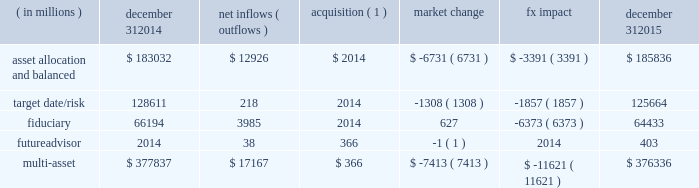Long-term product offerings include active and index strategies .
Our active strategies seek to earn attractive returns in excess of a market benchmark or performance hurdle while maintaining an appropriate risk profile .
We offer two types of active strategies : those that rely primarily on fundamental research and those that utilize primarily quantitative models to drive portfolio construction .
In contrast , index strategies seek to closely track the returns of a corresponding index , generally by investing in substantially the same underlying securities within the index or in a subset of those securities selected to approximate a similar risk and return profile of the index .
Index strategies include both our non-etf index products and ishares etfs .
Althoughmany clients use both active and index strategies , the application of these strategies may differ .
For example , clients may use index products to gain exposure to a market or asset class .
In addition , institutional non-etf index assignments tend to be very large ( multi-billion dollars ) and typically reflect low fee rates .
This has the potential to exaggerate the significance of net flows in institutional index products on blackrock 2019s revenues and earnings .
Equity year-end 2015 equity aum totaled $ 2.424 trillion , reflecting net inflows of $ 52.8 billion .
Net inflows included $ 78.4 billion and $ 4.2 billion into ishares and active products , respectively .
Ishares net inflows were driven by the core series and flows into broad developed market equity exposures , and active net inflows reflected demand for international equities .
Ishares and active net inflows were partially offset by non-etf index net outflows of $ 29.8 billion .
Blackrock 2019s effective fee rates fluctuate due to changes in aummix .
Approximately half of blackrock 2019s equity aum is tied to international markets , including emerging markets , which tend to have higher fee rates than u.s .
Equity strategies .
Accordingly , fluctuations in international equity markets , which do not consistently move in tandemwith u.s .
Markets , may have a greater impact on blackrock 2019s effective equity fee rates and revenues .
Fixed income fixed income aum ended 2015 at $ 1.422 trillion , increasing $ 28.7 billion , or 2% ( 2 % ) , from december 31 , 2014 .
The increase in aum reflected $ 76.9 billion in net inflows , partially offset by $ 48.2 billion in net market depreciation and foreign exchange movements .
In 2015 , active net inflows of $ 35.9 billion were diversified across fixed income offerings , with strong flows into our unconstrained , total return and high yield strategies .
Flagship funds in these product areas include our unconstrained strategic income opportunities and fixed income strategies funds , with net inflows of $ 7.0 billion and $ 3.7 billion , respectively ; our total return fund with net inflows of $ 2.7 billion ; and our high yield bond fund with net inflows of $ 3.5 billion .
Fixed income ishares net inflows of $ 50.3 billion were led by flows into core , corporate and high yield bond funds .
Active and ishares net inflows were partially offset by non-etf index net outflows of $ 9.3 billion .
Multi-asset class blackrock 2019s multi-asset class teammanages a variety of balanced funds and bespoke mandates for a diversified client base that leverages our broad investment expertise in global equities , bonds , currencies and commodities , and our extensive risk management capabilities .
Investment solutions might include a combination of long-only portfolios and alternative investments as well as tactical asset allocation overlays .
Component changes in multi-asset class aum for 2015 are presented below .
( in millions ) december 31 , 2014 net inflows ( outflows ) acquisition ( 1 ) market change fx impact december 31 , 2015 asset allocation and balanced $ 183032 $ 12926 $ 2014 $ ( 6731 ) $ ( 3391 ) $ 185836 .
( 1 ) amounts represent $ 366 million of aum acquired in the futureadvisor acquisition in october 2015 .
The futureadvisor acquisition amount does not include aum that was held in ishares holdings .
Multi-asset class net inflows reflected ongoing institutional demand for our solutions-based advice with $ 17.4 billion of net inflows coming from institutional clients .
Defined contribution plans of institutional clients remained a significant driver of flows , and contributed $ 7.3 billion to institutional multi-asset class net new business in 2015 , primarily into target date and target risk product offerings .
Retail net outflows of $ 1.3 billion were primarily due to a large single-client transition out of mutual funds into a series of ishares across asset classes .
Notwithstanding this transition , retail flows reflected demand for our multi-asset income fund family , which raised $ 4.6 billion in 2015 .
The company 2019s multi-asset class strategies include the following : 2022 asset allocation and balanced products represented 49% ( 49 % ) of multi-asset class aum at year-end , with growth in aum driven by net new business of $ 12.9 billion .
These strategies combine equity , fixed income and alternative components for investors seeking a tailored solution relative to a specific benchmark and within a risk budget .
In certain cases , these strategies seek to minimize downside risk through diversification , derivatives strategies and tactical asset allocation decisions .
Flagship products in this category include our global allocation andmulti-asset income suites. .
What is the growth rate in the balance of total multi assets from 2014 to 2015? 
Computations: ((376336 - 377837) / 377837)
Answer: -0.00397. 